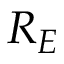<formula> <loc_0><loc_0><loc_500><loc_500>R _ { E }</formula> 